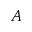Convert formula to latex. <formula><loc_0><loc_0><loc_500><loc_500>A</formula> 